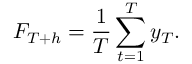<formula> <loc_0><loc_0><loc_500><loc_500>F _ { T + h } = \frac { 1 } { T } \sum _ { t = 1 } ^ { T } y _ { T } .</formula> 